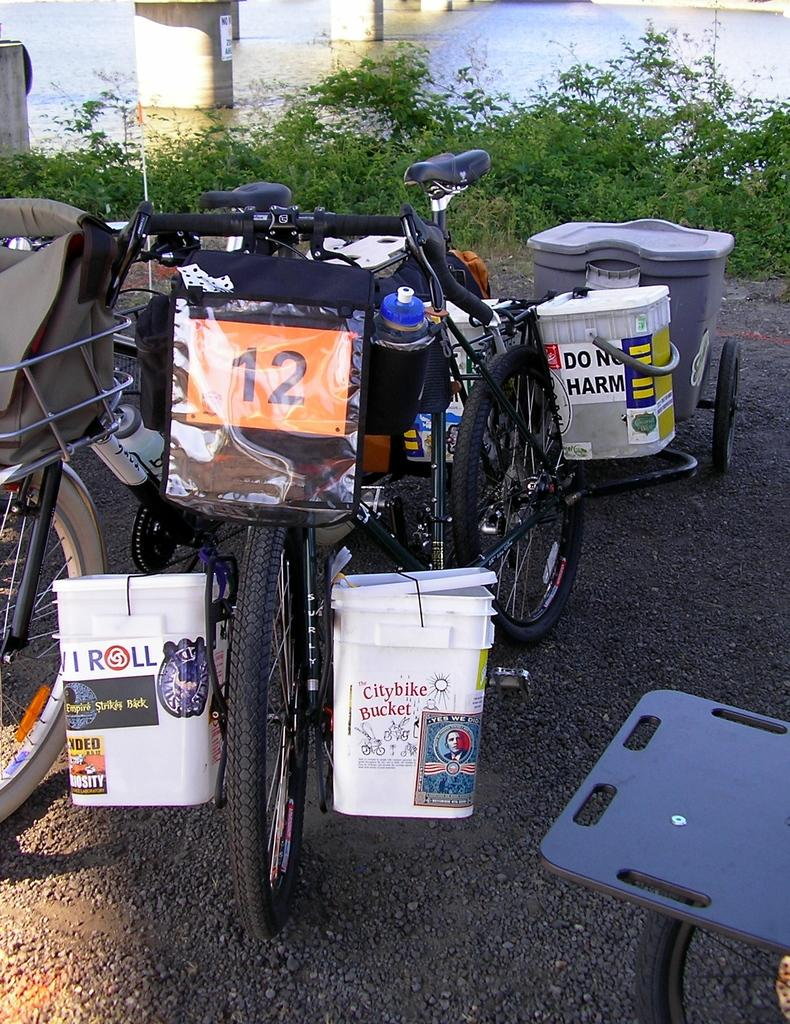What type of vehicles are present in the image? There are bicycles with luggage in the image. Where are the bicycles located? The bicycles are on the road in the image. What can be seen in the background of the image? There are plants visible in the image. What is unique about the water in the image? There are pillars in the water in the image. Can you see any fairies flying around the bicycles in the image? No, there are no fairies present in the image. What type of branch can be seen growing from the pillars in the water? There are no branches visible in the image, as it only shows pillars in the water. 